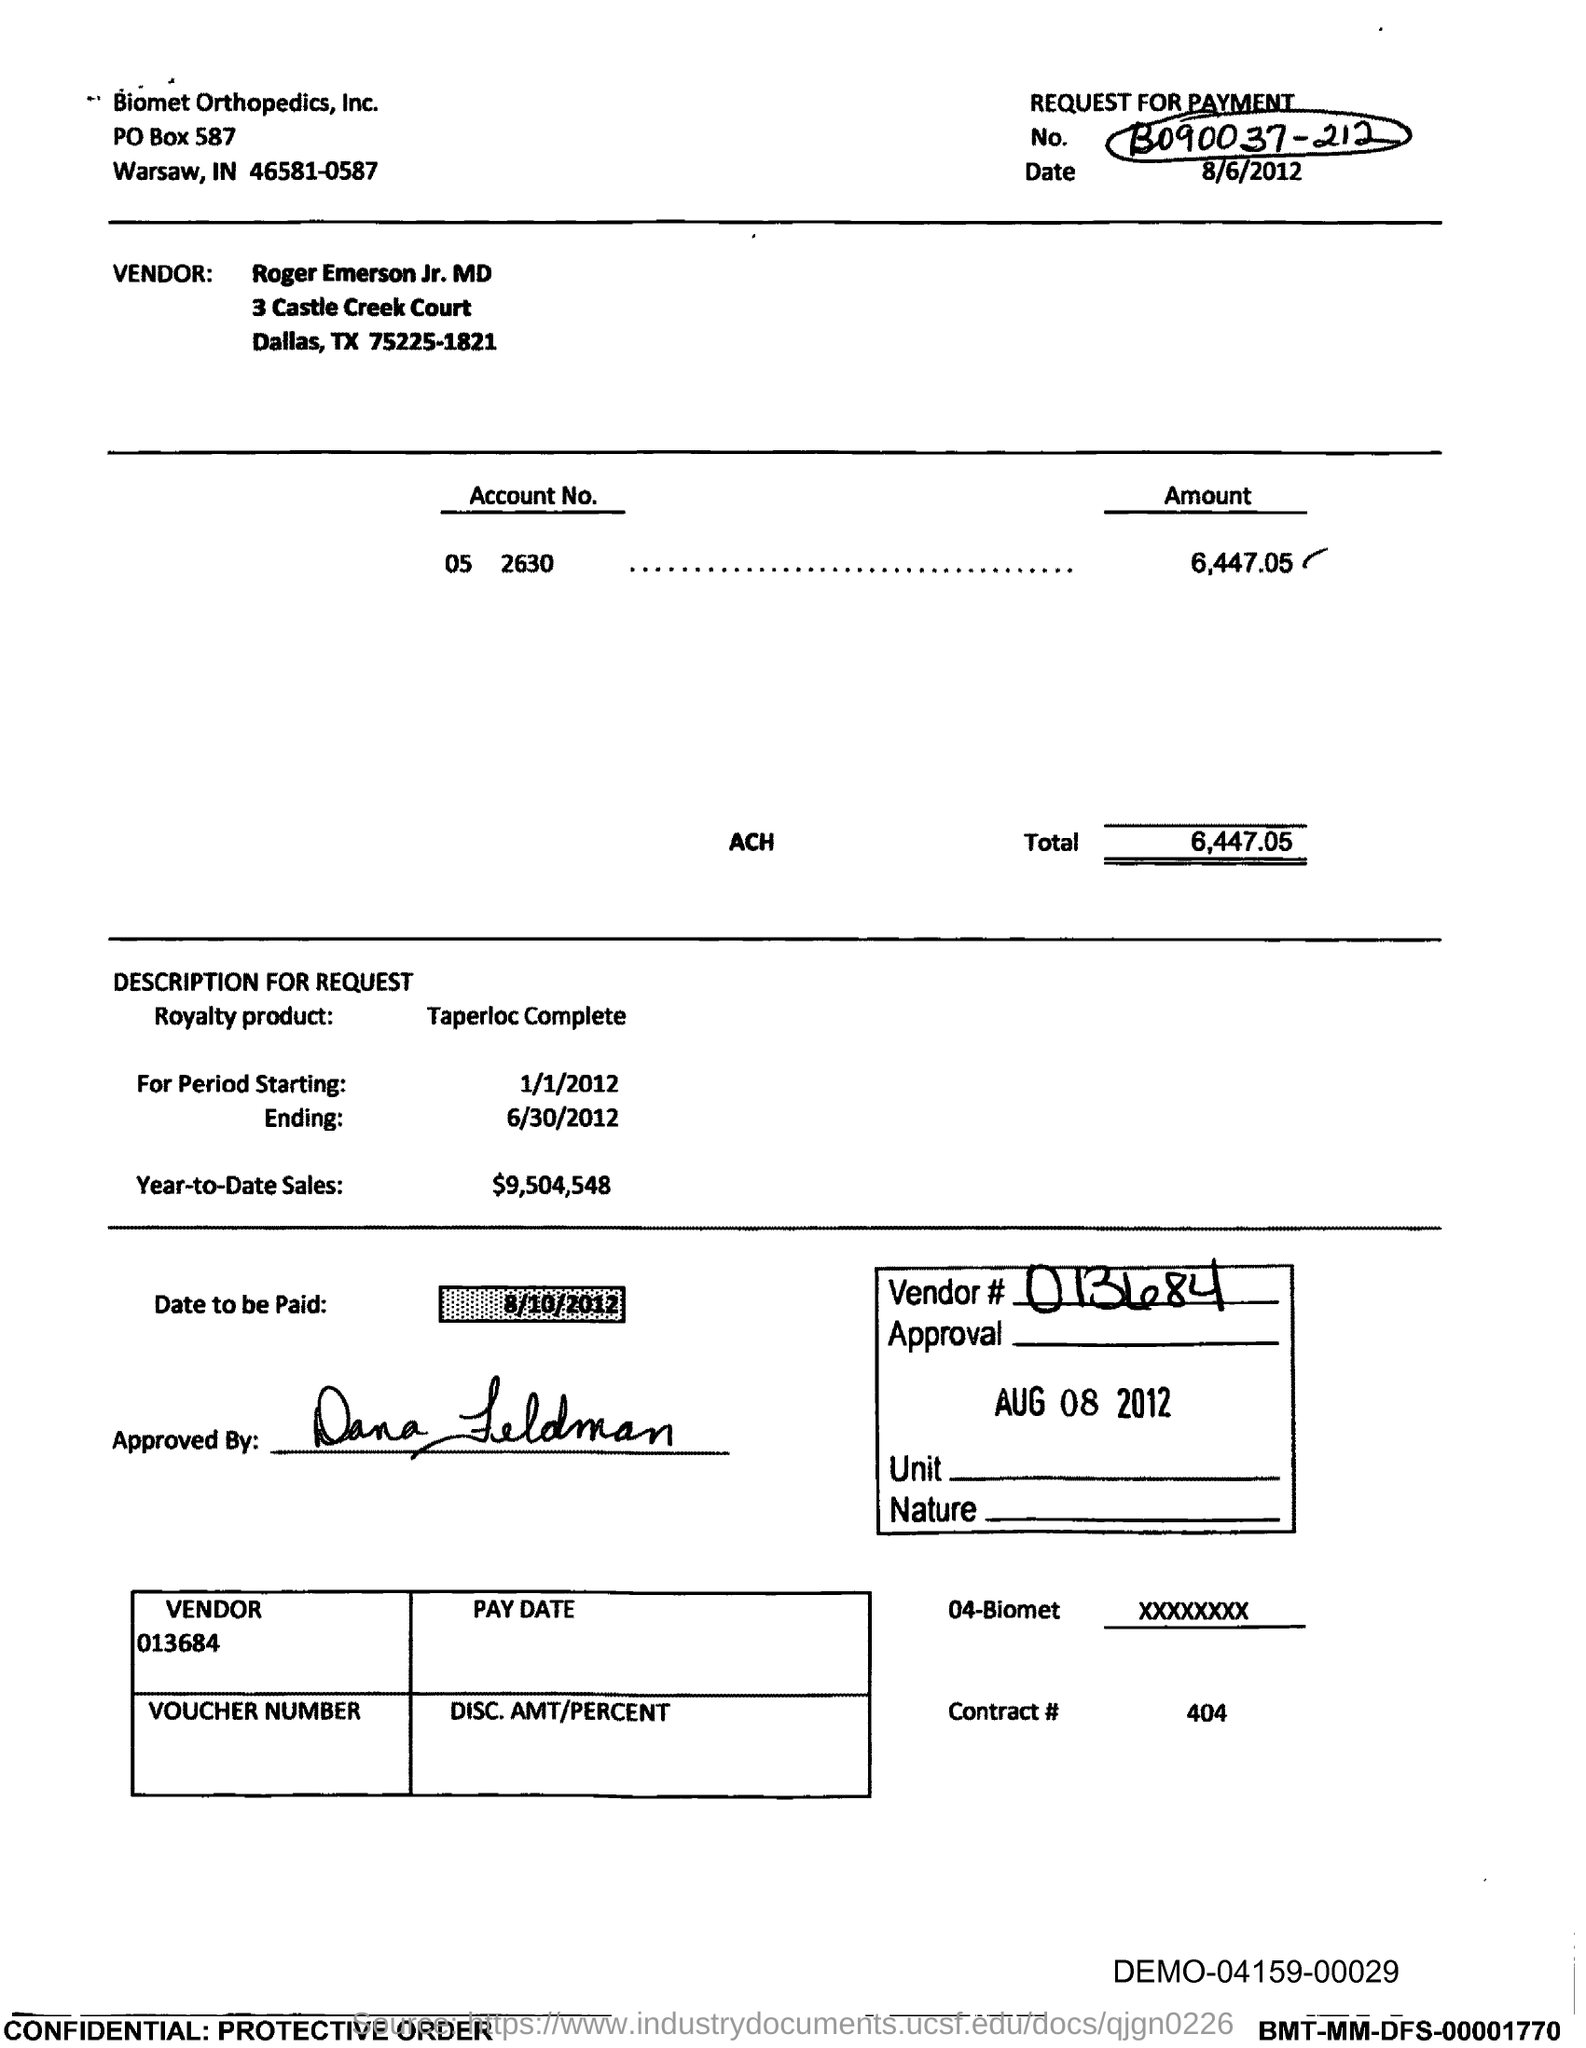What is the total?
Provide a succinct answer. 6,447.05. What is the contract# ?
Provide a short and direct response. 404. In which city is biomet orthopedics, inc.?
Make the answer very short. Warsaw. What is the po box no. of biomet orthopedics, inc. ?
Offer a terse response. 587. What is the date to be paid?
Keep it short and to the point. 8/10/2012. What is year-to-date sales?
Offer a terse response. $9,504,548. What is the royalty product name ?
Your answer should be very brief. Taperloc Complete. 